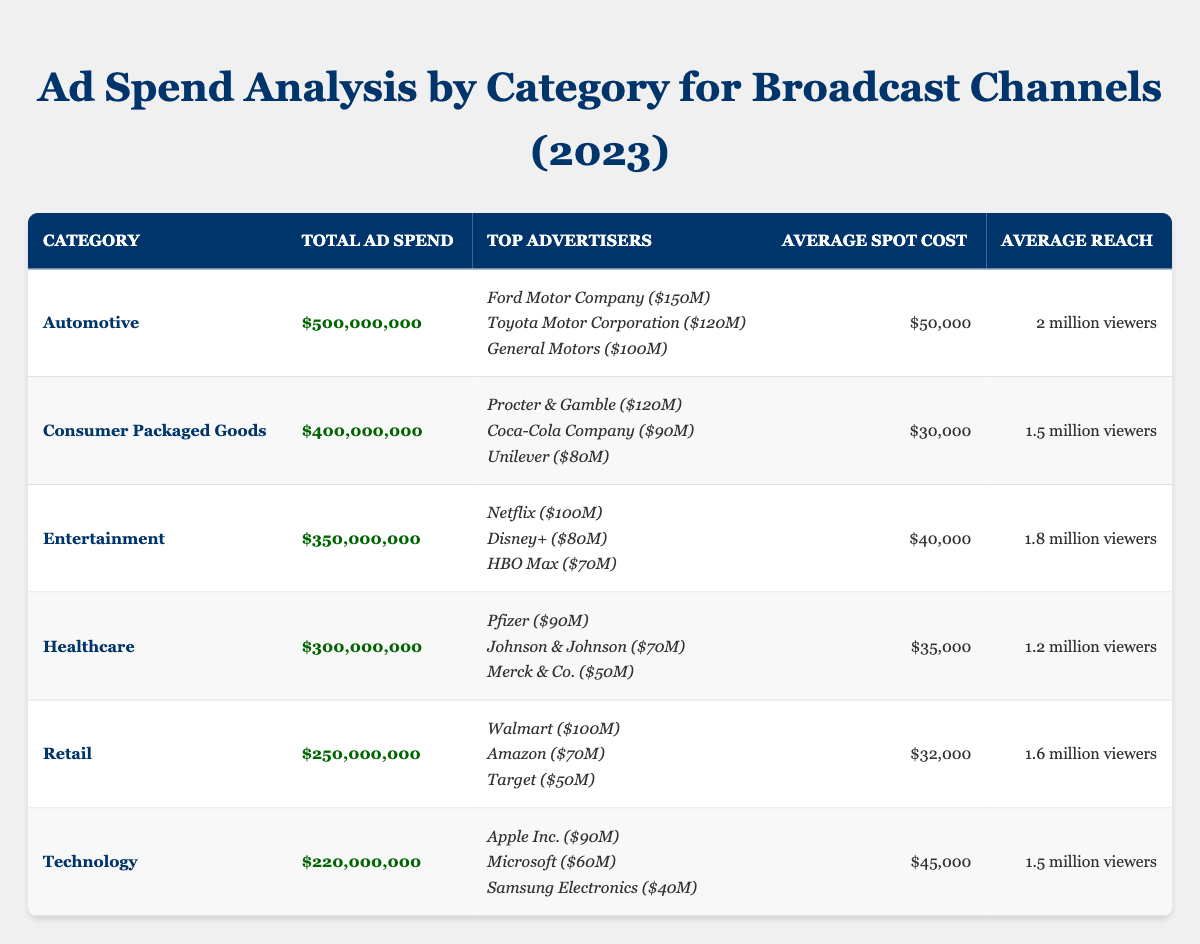What is the total ad spend for the Automotive category? The total ad spend for the Automotive category is directly presented in the table. It is listed as $500,000,000.
Answer: $500,000,000 Who spent the most in the Consumer Packaged Goods category? The table shows that Procter & Gamble spent the most at $120,000,000 in the Consumer Packaged Goods category.
Answer: Procter & Gamble What is the average spot cost for the Healthcare category? The average spot cost for the Healthcare category is listed in the table as $35,000.
Answer: $35,000 Which category has the highest total ad spend? By comparing the total ad spend across all categories, Automotive has the highest total at $500,000,000.
Answer: Automotive How much did Netflix spend on advertisements? The table states that Netflix spent $100,000,000 on advertisements in the Entertainment category.
Answer: $100,000,000 Calculate the combined ad spend for the top three advertisers in the Technology category. Summing the expenditures of Apple Inc. ($90M), Microsoft ($60M), and Samsung Electronics ($40M) gives us $90M + $60M + $40M = $190M.
Answer: $190,000,000 Does the average reach of the Retail category exceed 1.5 million viewers? The average reach of the Retail category is 1.6 million viewers, which is greater than 1.5 million viewers.
Answer: Yes What is the total ad spend for the top three advertisers in the Automotive category compared to the total ad spend for the entire category? The top three advertisers in Automotive spent a total of $150M (Ford) + $120M (Toyota) + $100M (General Motors) = $370M, which is less than the total category spend of $500M.
Answer: The top three advertisers spent less Which category shows the highest average reach, and what is that reach? By comparing the average reach figures for each category, Automotive has the highest average reach at 2 million viewers.
Answer: Automotive, 2 million viewers Is the total ad spend for Healthcare larger or smaller than the total ad spend for Entertainment? The total ad spend for Healthcare is $300M, while Entertainment has $350M, making Healthcare smaller than Entertainment.
Answer: Smaller 